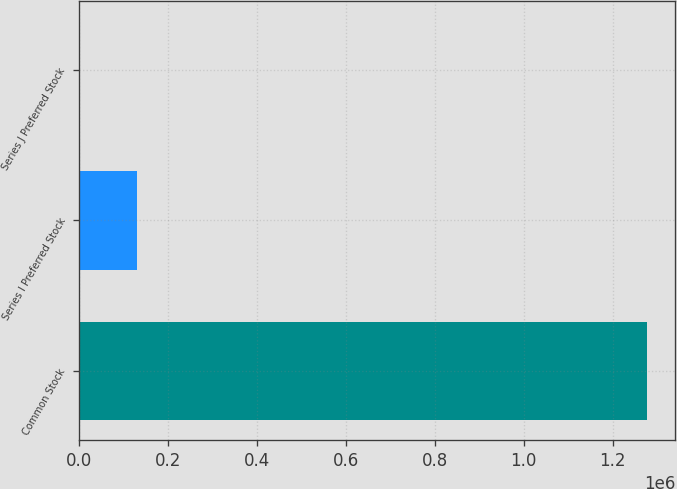Convert chart. <chart><loc_0><loc_0><loc_500><loc_500><bar_chart><fcel>Common Stock<fcel>Series I Preferred Stock<fcel>Series J Preferred Stock<nl><fcel>1.27732e+06<fcel>130161<fcel>2699<nl></chart> 